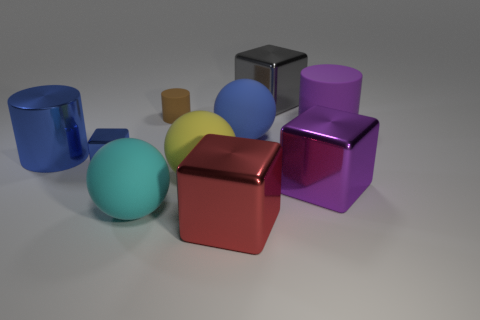Subtract 1 cubes. How many cubes are left? 3 Subtract all cyan cubes. Subtract all gray cylinders. How many cubes are left? 4 Subtract all blocks. How many objects are left? 6 Add 7 large blue cubes. How many large blue cubes exist? 7 Subtract 1 blue cylinders. How many objects are left? 9 Subtract all brown rubber cylinders. Subtract all gray things. How many objects are left? 8 Add 1 gray objects. How many gray objects are left? 2 